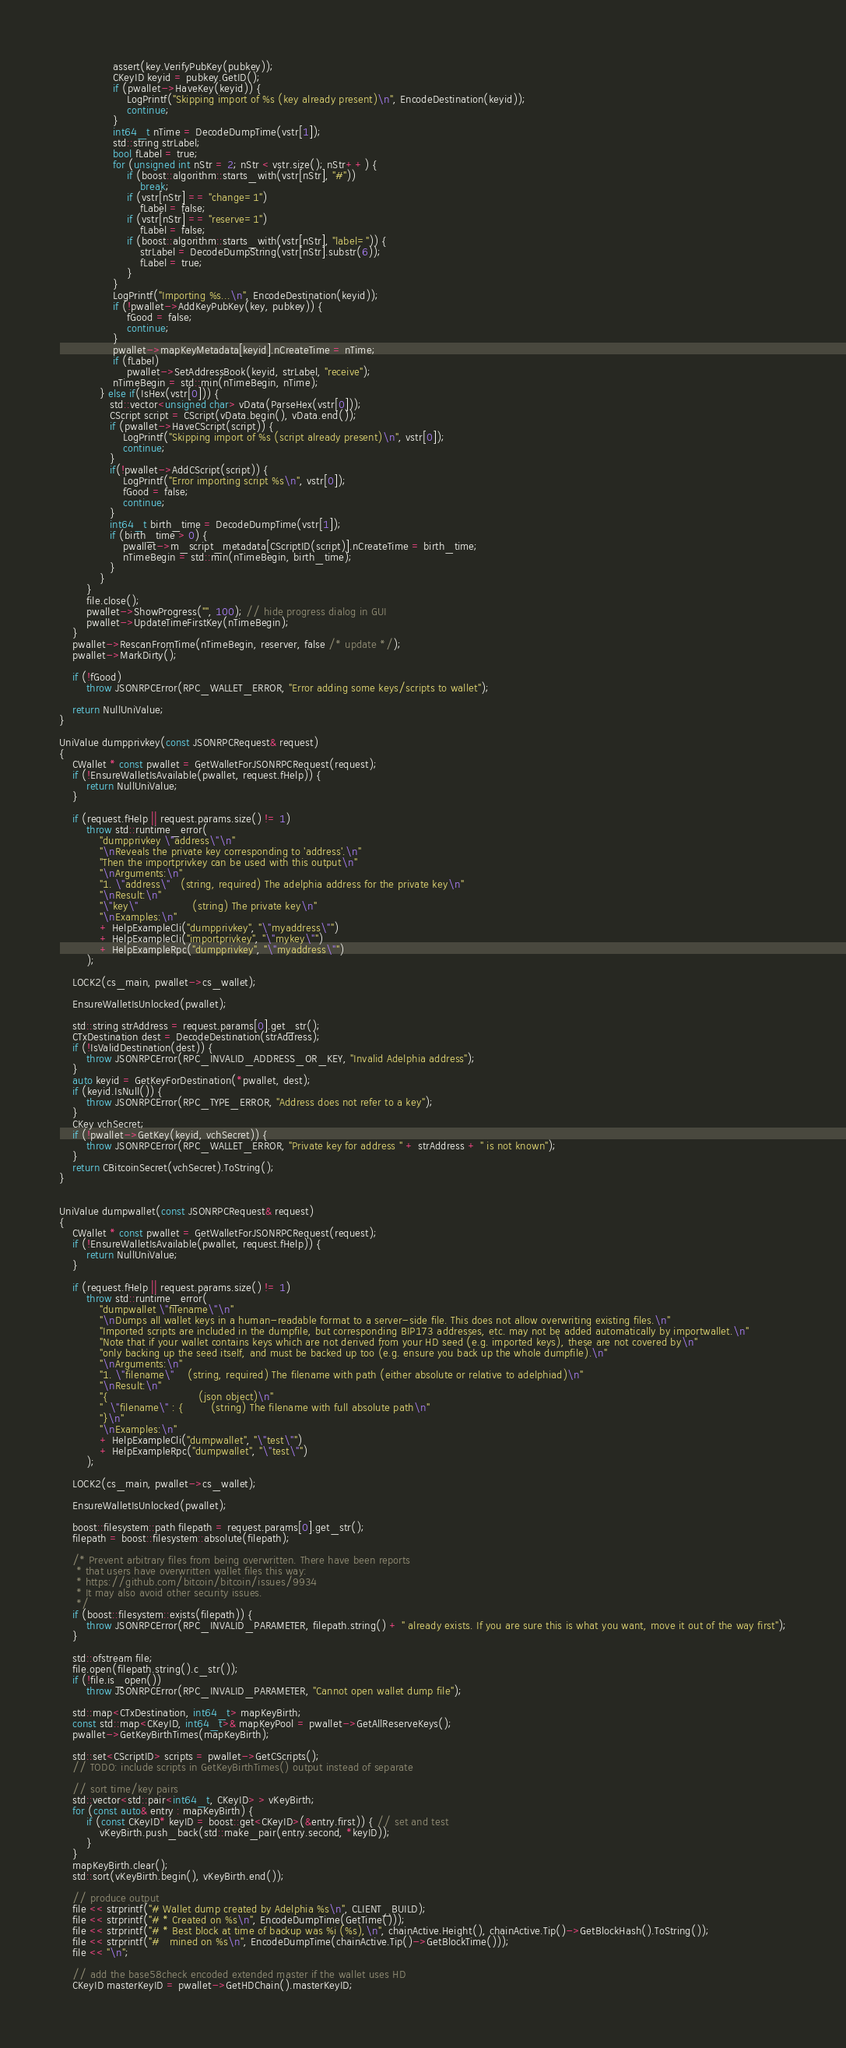Convert code to text. <code><loc_0><loc_0><loc_500><loc_500><_C++_>                assert(key.VerifyPubKey(pubkey));
                CKeyID keyid = pubkey.GetID();
                if (pwallet->HaveKey(keyid)) {
                    LogPrintf("Skipping import of %s (key already present)\n", EncodeDestination(keyid));
                    continue;
                }
                int64_t nTime = DecodeDumpTime(vstr[1]);
                std::string strLabel;
                bool fLabel = true;
                for (unsigned int nStr = 2; nStr < vstr.size(); nStr++) {
                    if (boost::algorithm::starts_with(vstr[nStr], "#"))
                        break;
                    if (vstr[nStr] == "change=1")
                        fLabel = false;
                    if (vstr[nStr] == "reserve=1")
                        fLabel = false;
                    if (boost::algorithm::starts_with(vstr[nStr], "label=")) {
                        strLabel = DecodeDumpString(vstr[nStr].substr(6));
                        fLabel = true;
                    }
                }
                LogPrintf("Importing %s...\n", EncodeDestination(keyid));
                if (!pwallet->AddKeyPubKey(key, pubkey)) {
                    fGood = false;
                    continue;
                }
                pwallet->mapKeyMetadata[keyid].nCreateTime = nTime;
                if (fLabel)
                    pwallet->SetAddressBook(keyid, strLabel, "receive");
                nTimeBegin = std::min(nTimeBegin, nTime);
            } else if(IsHex(vstr[0])) {
               std::vector<unsigned char> vData(ParseHex(vstr[0]));
               CScript script = CScript(vData.begin(), vData.end());
               if (pwallet->HaveCScript(script)) {
                   LogPrintf("Skipping import of %s (script already present)\n", vstr[0]);
                   continue;
               }
               if(!pwallet->AddCScript(script)) {
                   LogPrintf("Error importing script %s\n", vstr[0]);
                   fGood = false;
                   continue;
               }
               int64_t birth_time = DecodeDumpTime(vstr[1]);
               if (birth_time > 0) {
                   pwallet->m_script_metadata[CScriptID(script)].nCreateTime = birth_time;
                   nTimeBegin = std::min(nTimeBegin, birth_time);
               }
            }
        }
        file.close();
        pwallet->ShowProgress("", 100); // hide progress dialog in GUI
        pwallet->UpdateTimeFirstKey(nTimeBegin);
    }
    pwallet->RescanFromTime(nTimeBegin, reserver, false /* update */);
    pwallet->MarkDirty();

    if (!fGood)
        throw JSONRPCError(RPC_WALLET_ERROR, "Error adding some keys/scripts to wallet");

    return NullUniValue;
}

UniValue dumpprivkey(const JSONRPCRequest& request)
{
    CWallet * const pwallet = GetWalletForJSONRPCRequest(request);
    if (!EnsureWalletIsAvailable(pwallet, request.fHelp)) {
        return NullUniValue;
    }

    if (request.fHelp || request.params.size() != 1)
        throw std::runtime_error(
            "dumpprivkey \"address\"\n"
            "\nReveals the private key corresponding to 'address'.\n"
            "Then the importprivkey can be used with this output\n"
            "\nArguments:\n"
            "1. \"address\"   (string, required) The adelphia address for the private key\n"
            "\nResult:\n"
            "\"key\"                (string) The private key\n"
            "\nExamples:\n"
            + HelpExampleCli("dumpprivkey", "\"myaddress\"")
            + HelpExampleCli("importprivkey", "\"mykey\"")
            + HelpExampleRpc("dumpprivkey", "\"myaddress\"")
        );

    LOCK2(cs_main, pwallet->cs_wallet);

    EnsureWalletIsUnlocked(pwallet);

    std::string strAddress = request.params[0].get_str();
    CTxDestination dest = DecodeDestination(strAddress);
    if (!IsValidDestination(dest)) {
        throw JSONRPCError(RPC_INVALID_ADDRESS_OR_KEY, "Invalid Adelphia address");
    }
    auto keyid = GetKeyForDestination(*pwallet, dest);
    if (keyid.IsNull()) {
        throw JSONRPCError(RPC_TYPE_ERROR, "Address does not refer to a key");
    }
    CKey vchSecret;
    if (!pwallet->GetKey(keyid, vchSecret)) {
        throw JSONRPCError(RPC_WALLET_ERROR, "Private key for address " + strAddress + " is not known");
    }
    return CBitcoinSecret(vchSecret).ToString();
}


UniValue dumpwallet(const JSONRPCRequest& request)
{
    CWallet * const pwallet = GetWalletForJSONRPCRequest(request);
    if (!EnsureWalletIsAvailable(pwallet, request.fHelp)) {
        return NullUniValue;
    }

    if (request.fHelp || request.params.size() != 1)
        throw std::runtime_error(
            "dumpwallet \"filename\"\n"
            "\nDumps all wallet keys in a human-readable format to a server-side file. This does not allow overwriting existing files.\n"
            "Imported scripts are included in the dumpfile, but corresponding BIP173 addresses, etc. may not be added automatically by importwallet.\n"
            "Note that if your wallet contains keys which are not derived from your HD seed (e.g. imported keys), these are not covered by\n"
            "only backing up the seed itself, and must be backed up too (e.g. ensure you back up the whole dumpfile).\n"
            "\nArguments:\n"
            "1. \"filename\"    (string, required) The filename with path (either absolute or relative to adelphiad)\n"
            "\nResult:\n"
            "{                           (json object)\n"
            "  \"filename\" : {        (string) The filename with full absolute path\n"
            "}\n"
            "\nExamples:\n"
            + HelpExampleCli("dumpwallet", "\"test\"")
            + HelpExampleRpc("dumpwallet", "\"test\"")
        );

    LOCK2(cs_main, pwallet->cs_wallet);

    EnsureWalletIsUnlocked(pwallet);

    boost::filesystem::path filepath = request.params[0].get_str();
    filepath = boost::filesystem::absolute(filepath);

    /* Prevent arbitrary files from being overwritten. There have been reports
     * that users have overwritten wallet files this way:
     * https://github.com/bitcoin/bitcoin/issues/9934
     * It may also avoid other security issues.
     */
    if (boost::filesystem::exists(filepath)) {
        throw JSONRPCError(RPC_INVALID_PARAMETER, filepath.string() + " already exists. If you are sure this is what you want, move it out of the way first");
    }

    std::ofstream file;
    file.open(filepath.string().c_str());
    if (!file.is_open())
        throw JSONRPCError(RPC_INVALID_PARAMETER, "Cannot open wallet dump file");

    std::map<CTxDestination, int64_t> mapKeyBirth;
    const std::map<CKeyID, int64_t>& mapKeyPool = pwallet->GetAllReserveKeys();
    pwallet->GetKeyBirthTimes(mapKeyBirth);

    std::set<CScriptID> scripts = pwallet->GetCScripts();
    // TODO: include scripts in GetKeyBirthTimes() output instead of separate

    // sort time/key pairs
    std::vector<std::pair<int64_t, CKeyID> > vKeyBirth;
    for (const auto& entry : mapKeyBirth) {
        if (const CKeyID* keyID = boost::get<CKeyID>(&entry.first)) { // set and test
            vKeyBirth.push_back(std::make_pair(entry.second, *keyID));
        }
    }
    mapKeyBirth.clear();
    std::sort(vKeyBirth.begin(), vKeyBirth.end());

    // produce output
    file << strprintf("# Wallet dump created by Adelphia %s\n", CLIENT_BUILD);
    file << strprintf("# * Created on %s\n", EncodeDumpTime(GetTime()));
    file << strprintf("# * Best block at time of backup was %i (%s),\n", chainActive.Height(), chainActive.Tip()->GetBlockHash().ToString());
    file << strprintf("#   mined on %s\n", EncodeDumpTime(chainActive.Tip()->GetBlockTime()));
    file << "\n";

    // add the base58check encoded extended master if the wallet uses HD
    CKeyID masterKeyID = pwallet->GetHDChain().masterKeyID;</code> 